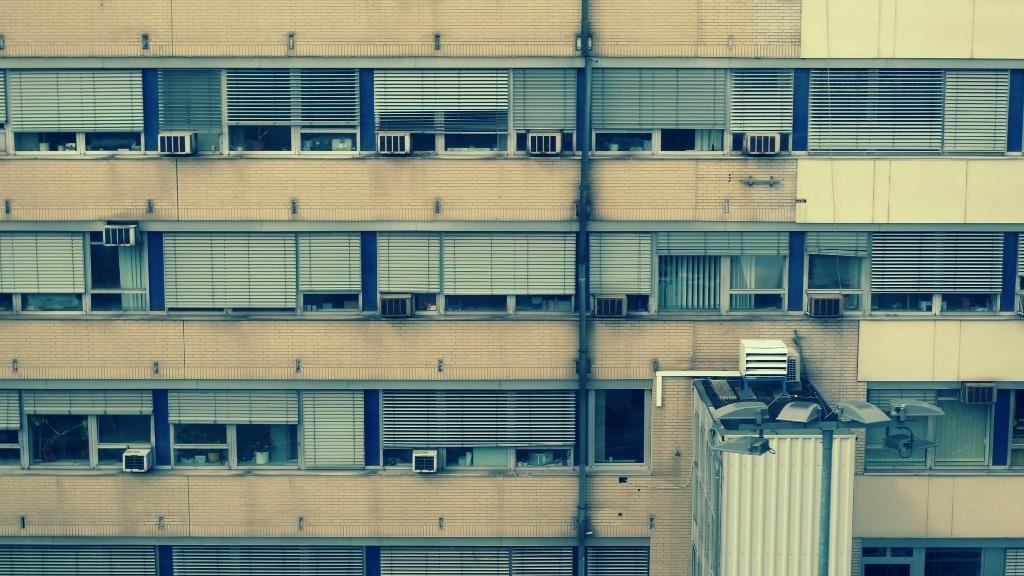How would you summarize this image in a sentence or two? In this image, we can see a building with the window blinds and objects attached to it. We can also see a white colored object with some objects placed on it. We can also see a pole with some objects. 